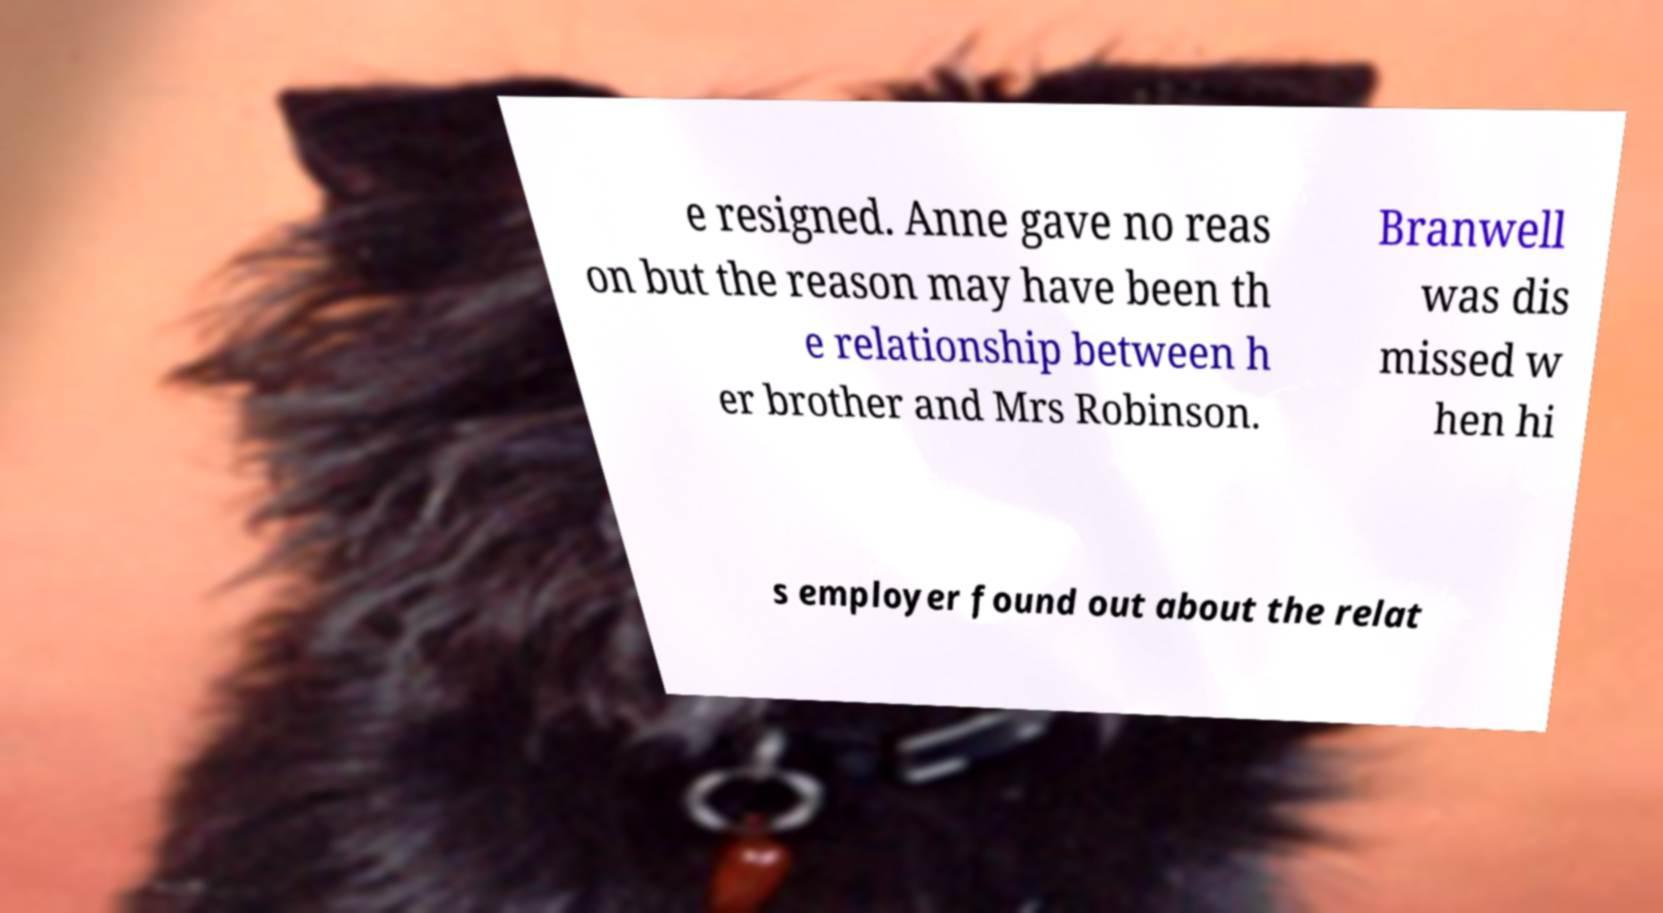I need the written content from this picture converted into text. Can you do that? e resigned. Anne gave no reas on but the reason may have been th e relationship between h er brother and Mrs Robinson. Branwell was dis missed w hen hi s employer found out about the relat 